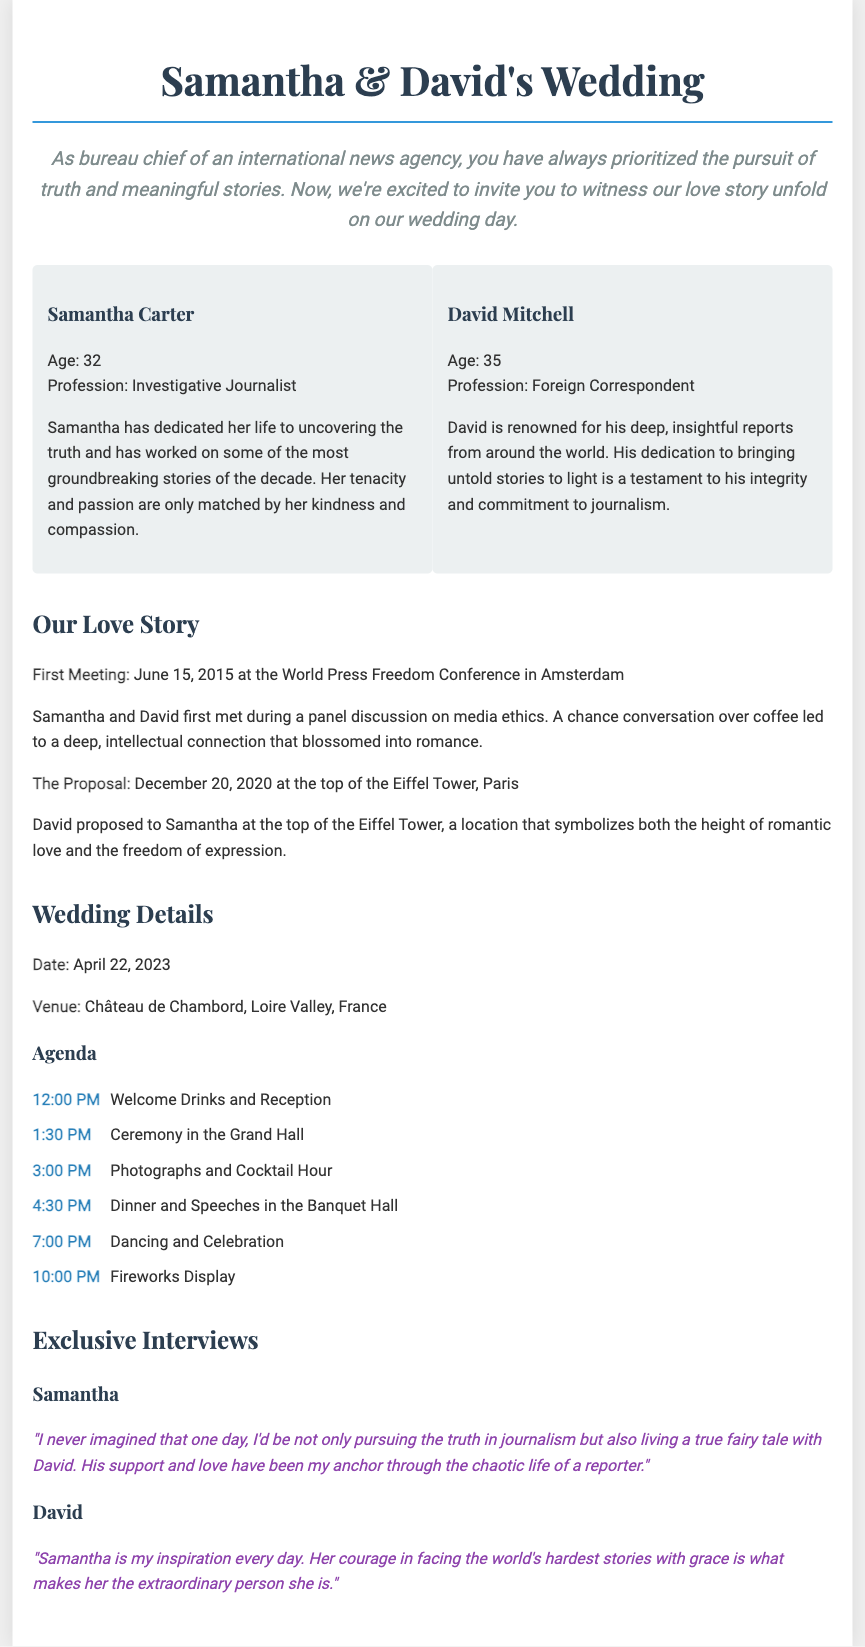What is the date of the wedding? The date of the wedding is clearly stated in the "Wedding Details" section of the document.
Answer: April 22, 2023 Who proposed to Samantha? The document mentions David proposing to Samantha at the Eiffel Tower.
Answer: David What is Samantha's profession? Her profession is specified in the couple's biography section, where her role is described.
Answer: Investigative Journalist Where did Samantha and David first meet? Their first meeting location is given in the "Our Love Story" section of the document.
Answer: World Press Freedom Conference, Amsterdam What time does the ceremony begin? The start time for the ceremony is listed in the agenda under the "Wedding Details" section.
Answer: 1:30 PM What was the location of the proposal? The document gives the specific location where David proposed to Samantha.
Answer: Eiffel Tower, Paris How many people are in the couple's bio? The "couple-bio" section lists information about two individuals.
Answer: Two What does David think of Samantha? In the exclusive interview with David, he shares his admiration for Samantha's character.
Answer: "Samantha is my inspiration every day." What is the name of the wedding venue? The name of the venue where the wedding will take place is included in the "Wedding Details" section.
Answer: Château de Chambord, Loire Valley, France 